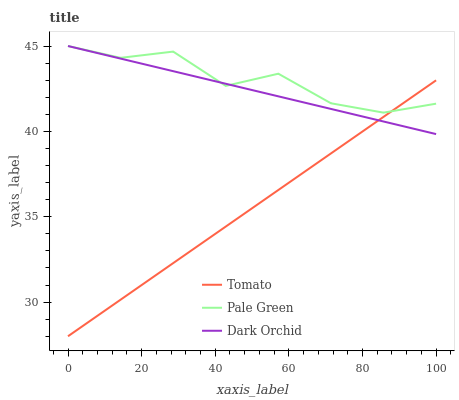Does Tomato have the minimum area under the curve?
Answer yes or no. Yes. Does Pale Green have the maximum area under the curve?
Answer yes or no. Yes. Does Dark Orchid have the minimum area under the curve?
Answer yes or no. No. Does Dark Orchid have the maximum area under the curve?
Answer yes or no. No. Is Dark Orchid the smoothest?
Answer yes or no. Yes. Is Pale Green the roughest?
Answer yes or no. Yes. Is Pale Green the smoothest?
Answer yes or no. No. Is Dark Orchid the roughest?
Answer yes or no. No. Does Tomato have the lowest value?
Answer yes or no. Yes. Does Dark Orchid have the lowest value?
Answer yes or no. No. Does Dark Orchid have the highest value?
Answer yes or no. Yes. Does Pale Green intersect Dark Orchid?
Answer yes or no. Yes. Is Pale Green less than Dark Orchid?
Answer yes or no. No. Is Pale Green greater than Dark Orchid?
Answer yes or no. No. 